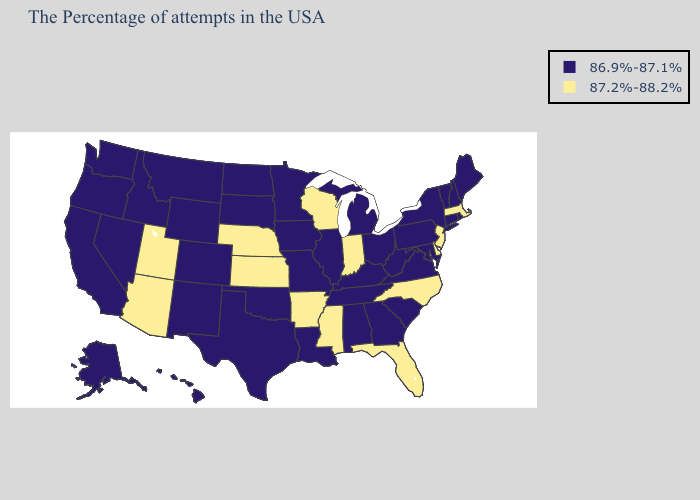Name the states that have a value in the range 87.2%-88.2%?
Be succinct. Massachusetts, New Jersey, Delaware, North Carolina, Florida, Indiana, Wisconsin, Mississippi, Arkansas, Kansas, Nebraska, Utah, Arizona. Name the states that have a value in the range 86.9%-87.1%?
Give a very brief answer. Maine, Rhode Island, New Hampshire, Vermont, Connecticut, New York, Maryland, Pennsylvania, Virginia, South Carolina, West Virginia, Ohio, Georgia, Michigan, Kentucky, Alabama, Tennessee, Illinois, Louisiana, Missouri, Minnesota, Iowa, Oklahoma, Texas, South Dakota, North Dakota, Wyoming, Colorado, New Mexico, Montana, Idaho, Nevada, California, Washington, Oregon, Alaska, Hawaii. Name the states that have a value in the range 86.9%-87.1%?
Keep it brief. Maine, Rhode Island, New Hampshire, Vermont, Connecticut, New York, Maryland, Pennsylvania, Virginia, South Carolina, West Virginia, Ohio, Georgia, Michigan, Kentucky, Alabama, Tennessee, Illinois, Louisiana, Missouri, Minnesota, Iowa, Oklahoma, Texas, South Dakota, North Dakota, Wyoming, Colorado, New Mexico, Montana, Idaho, Nevada, California, Washington, Oregon, Alaska, Hawaii. What is the lowest value in the MidWest?
Answer briefly. 86.9%-87.1%. Does South Dakota have a lower value than North Dakota?
Keep it brief. No. Which states have the lowest value in the West?
Answer briefly. Wyoming, Colorado, New Mexico, Montana, Idaho, Nevada, California, Washington, Oregon, Alaska, Hawaii. What is the lowest value in the West?
Short answer required. 86.9%-87.1%. Is the legend a continuous bar?
Quick response, please. No. Does the map have missing data?
Give a very brief answer. No. What is the value of Florida?
Quick response, please. 87.2%-88.2%. Among the states that border Utah , which have the lowest value?
Be succinct. Wyoming, Colorado, New Mexico, Idaho, Nevada. What is the highest value in states that border California?
Write a very short answer. 87.2%-88.2%. What is the value of Pennsylvania?
Keep it brief. 86.9%-87.1%. Name the states that have a value in the range 86.9%-87.1%?
Answer briefly. Maine, Rhode Island, New Hampshire, Vermont, Connecticut, New York, Maryland, Pennsylvania, Virginia, South Carolina, West Virginia, Ohio, Georgia, Michigan, Kentucky, Alabama, Tennessee, Illinois, Louisiana, Missouri, Minnesota, Iowa, Oklahoma, Texas, South Dakota, North Dakota, Wyoming, Colorado, New Mexico, Montana, Idaho, Nevada, California, Washington, Oregon, Alaska, Hawaii. How many symbols are there in the legend?
Keep it brief. 2. 